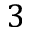Convert formula to latex. <formula><loc_0><loc_0><loc_500><loc_500>3</formula> 